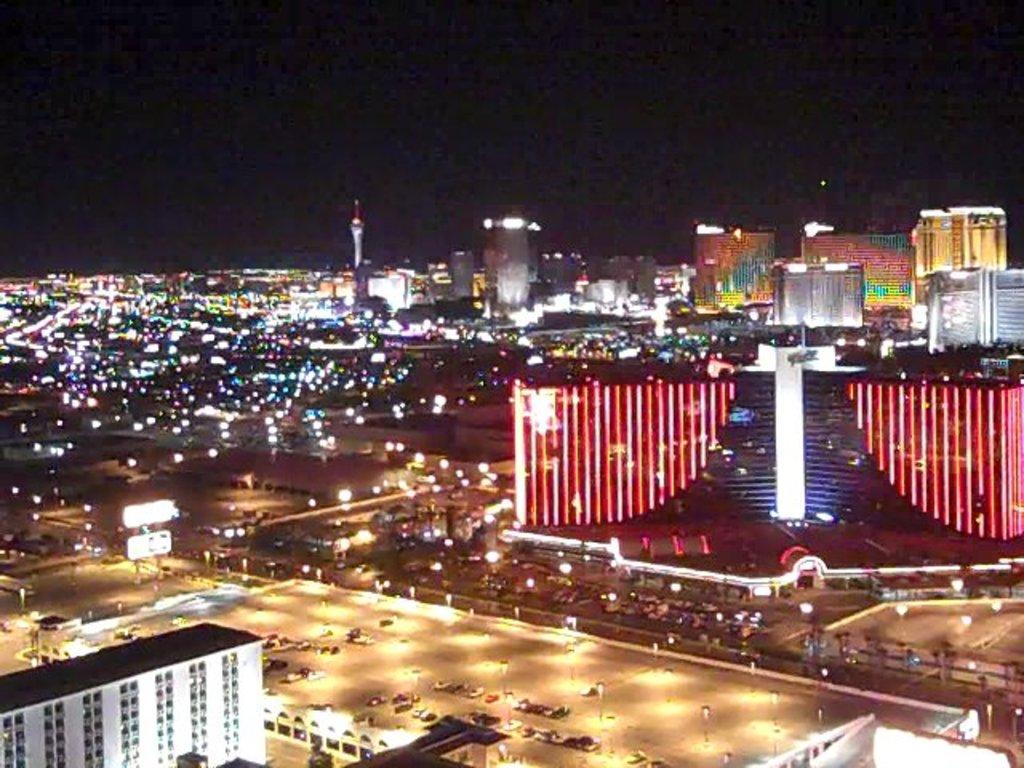What type of structures can be seen in the image? There are buildings in the image. What other objects are present in the image? There are light poles and vehicles in the image. What is the color of the background in the image? The background of the image is black. Can you tell me how many people are pushing the buildings in the image? There are no people pushing the buildings in the image; they are stationary structures. What sense is being used to experience the image? The image is visual, so the sense being used is sight. 